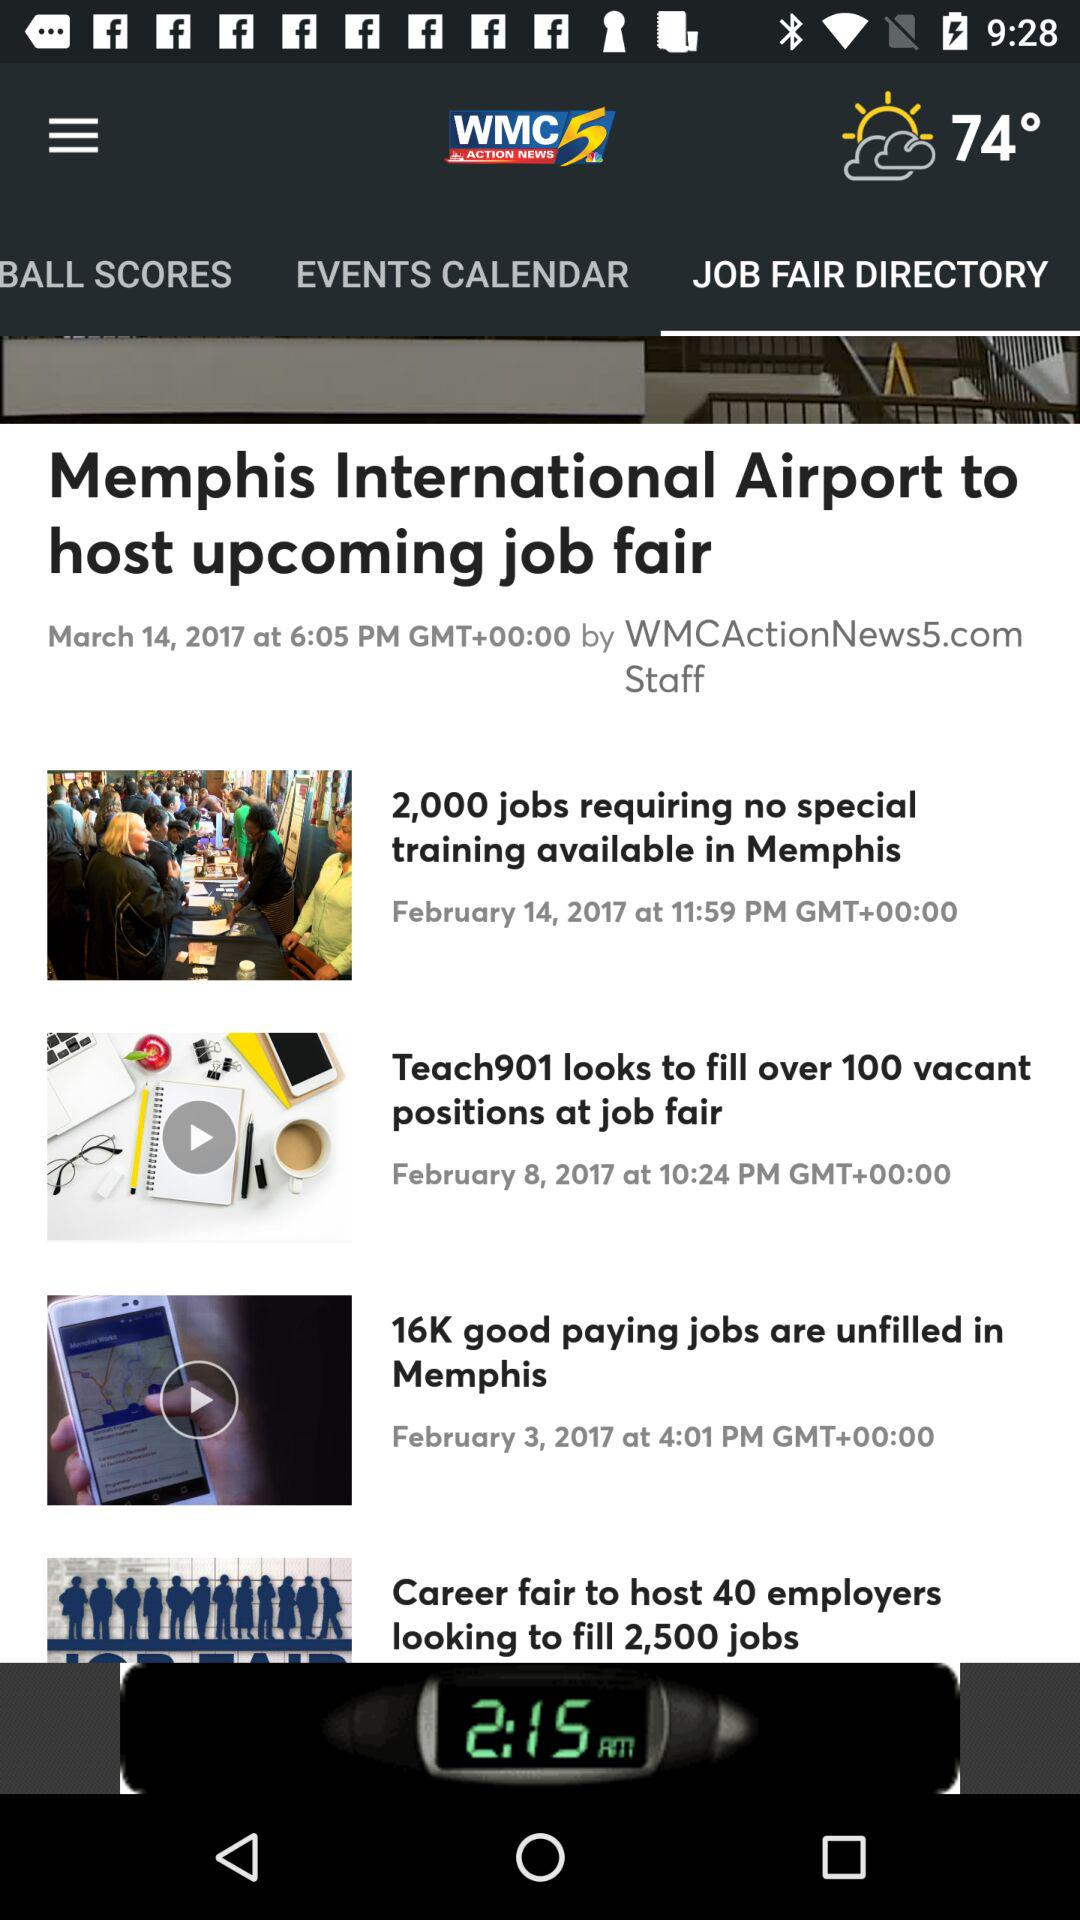Which tab is selected? The selected tab is "JOB FAIR DIRECTORY". 